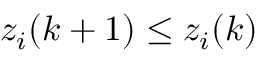<formula> <loc_0><loc_0><loc_500><loc_500>z _ { i } ( k + 1 ) \leq z _ { i } ( k )</formula> 